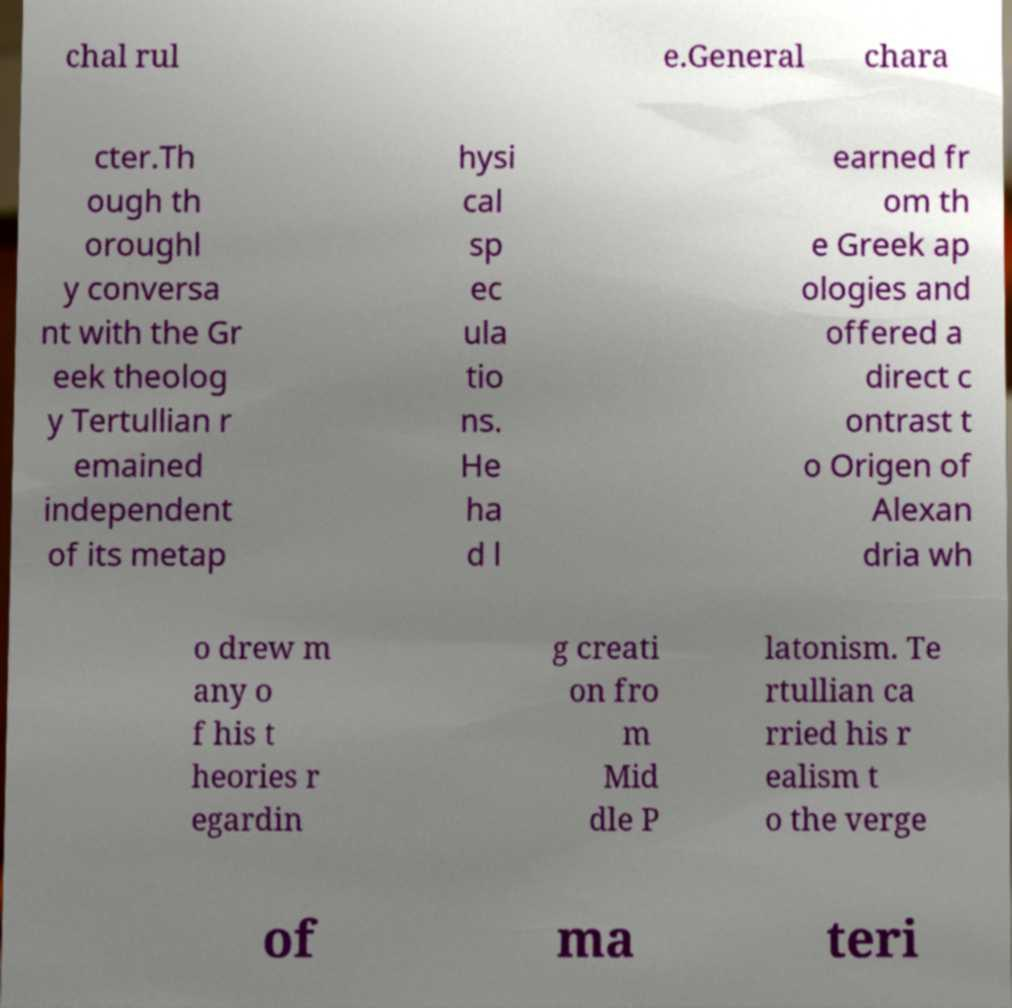Please read and relay the text visible in this image. What does it say? chal rul e.General chara cter.Th ough th oroughl y conversa nt with the Gr eek theolog y Tertullian r emained independent of its metap hysi cal sp ec ula tio ns. He ha d l earned fr om th e Greek ap ologies and offered a direct c ontrast t o Origen of Alexan dria wh o drew m any o f his t heories r egardin g creati on fro m Mid dle P latonism. Te rtullian ca rried his r ealism t o the verge of ma teri 